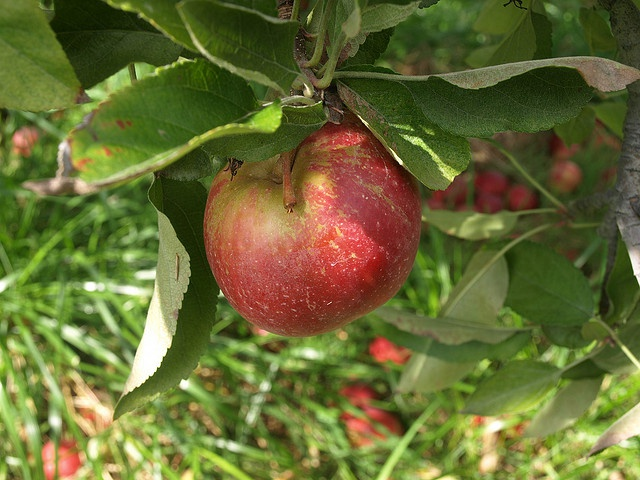Describe the objects in this image and their specific colors. I can see apple in olive, maroon, and brown tones, apple in olive, brown, and maroon tones, apple in olive, salmon, and brown tones, apple in olive, tan, and lightyellow tones, and apple in olive, maroon, and brown tones in this image. 